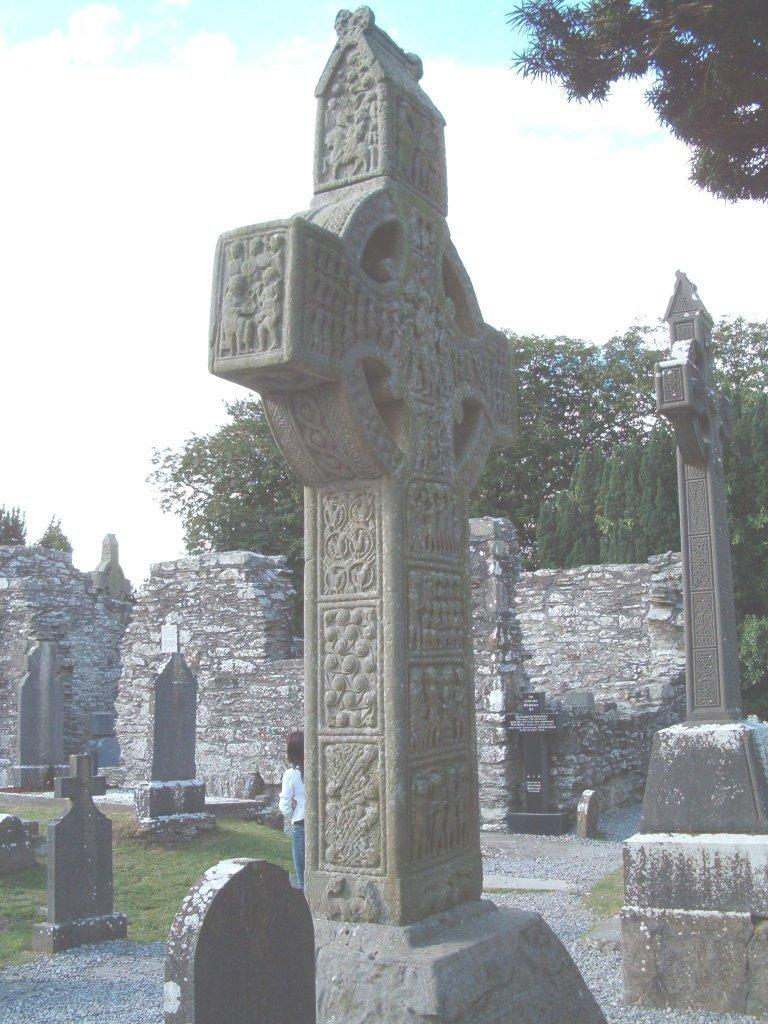What type of objects can be seen in the image that are related to remembrance? There are memorial stones in the image. What type of vegetation is present in the image? There is grass in the image. Can you describe the person in the image? There is a person in the image. What type of structures can be seen in the image? There are walls in the image. What other natural elements are present in the image? There are trees in the image. What is visible in the background of the image? The sky is visible in the image. What type of cracker is being used to clean the memorial stones in the image? There is no cracker present in the image, and therefore no such activity can be observed. Can you tell me how many trains are visible in the image? There are no trains present in the image. 